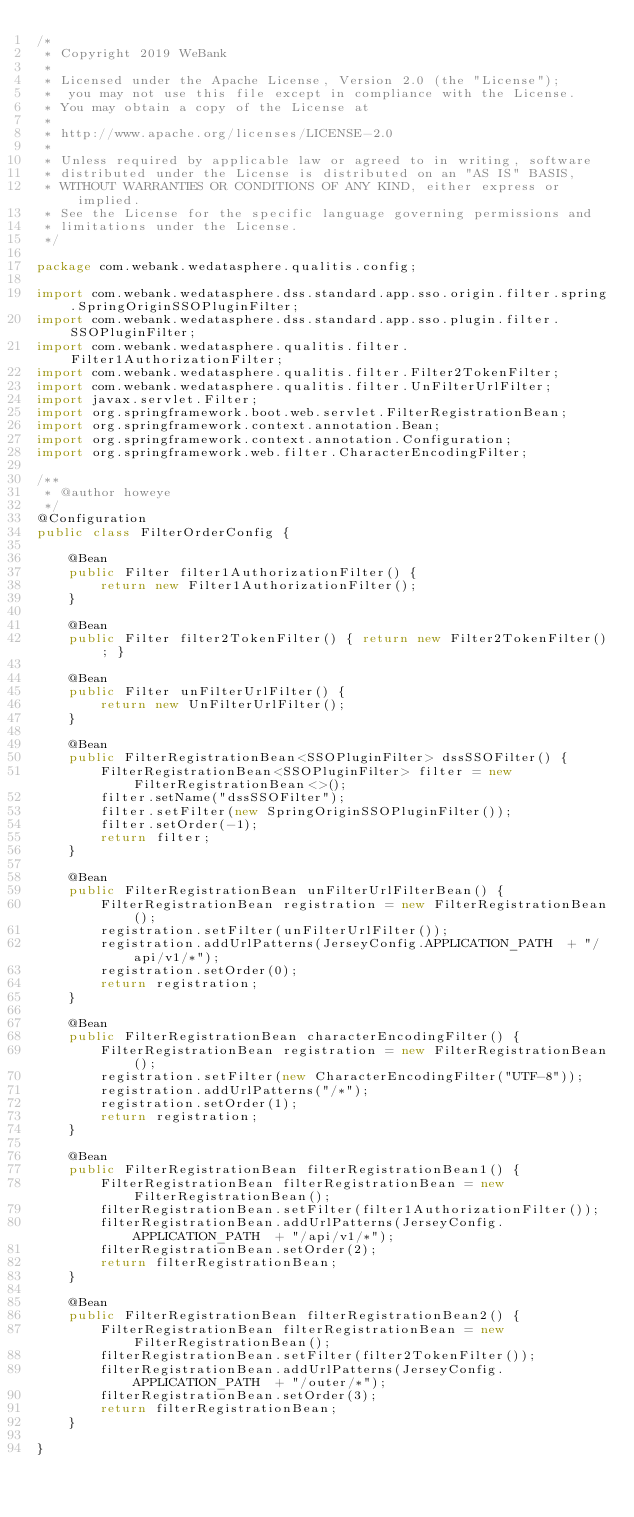<code> <loc_0><loc_0><loc_500><loc_500><_Java_>/*
 * Copyright 2019 WeBank
 *
 * Licensed under the Apache License, Version 2.0 (the "License");
 *  you may not use this file except in compliance with the License.
 * You may obtain a copy of the License at
 *
 * http://www.apache.org/licenses/LICENSE-2.0
 *
 * Unless required by applicable law or agreed to in writing, software
 * distributed under the License is distributed on an "AS IS" BASIS,
 * WITHOUT WARRANTIES OR CONDITIONS OF ANY KIND, either express or implied.
 * See the License for the specific language governing permissions and
 * limitations under the License.
 */

package com.webank.wedatasphere.qualitis.config;

import com.webank.wedatasphere.dss.standard.app.sso.origin.filter.spring.SpringOriginSSOPluginFilter;
import com.webank.wedatasphere.dss.standard.app.sso.plugin.filter.SSOPluginFilter;
import com.webank.wedatasphere.qualitis.filter.Filter1AuthorizationFilter;
import com.webank.wedatasphere.qualitis.filter.Filter2TokenFilter;
import com.webank.wedatasphere.qualitis.filter.UnFilterUrlFilter;
import javax.servlet.Filter;
import org.springframework.boot.web.servlet.FilterRegistrationBean;
import org.springframework.context.annotation.Bean;
import org.springframework.context.annotation.Configuration;
import org.springframework.web.filter.CharacterEncodingFilter;

/**
 * @author howeye
 */
@Configuration
public class FilterOrderConfig {

    @Bean
    public Filter filter1AuthorizationFilter() {
        return new Filter1AuthorizationFilter();
    }

    @Bean
    public Filter filter2TokenFilter() { return new Filter2TokenFilter(); }

    @Bean
    public Filter unFilterUrlFilter() {
        return new UnFilterUrlFilter();
    }

    @Bean
    public FilterRegistrationBean<SSOPluginFilter> dssSSOFilter() {
        FilterRegistrationBean<SSOPluginFilter> filter = new FilterRegistrationBean<>();
        filter.setName("dssSSOFilter");
        filter.setFilter(new SpringOriginSSOPluginFilter());
        filter.setOrder(-1);
        return filter;
    }

    @Bean
    public FilterRegistrationBean unFilterUrlFilterBean() {
        FilterRegistrationBean registration = new FilterRegistrationBean();
        registration.setFilter(unFilterUrlFilter());
        registration.addUrlPatterns(JerseyConfig.APPLICATION_PATH  + "/api/v1/*");
        registration.setOrder(0);
        return registration;
    }

    @Bean
    public FilterRegistrationBean characterEncodingFilter() {
        FilterRegistrationBean registration = new FilterRegistrationBean();
        registration.setFilter(new CharacterEncodingFilter("UTF-8"));
        registration.addUrlPatterns("/*");
        registration.setOrder(1);
        return registration;
    }

    @Bean
    public FilterRegistrationBean filterRegistrationBean1() {
        FilterRegistrationBean filterRegistrationBean = new FilterRegistrationBean();
        filterRegistrationBean.setFilter(filter1AuthorizationFilter());
        filterRegistrationBean.addUrlPatterns(JerseyConfig.APPLICATION_PATH  + "/api/v1/*");
        filterRegistrationBean.setOrder(2);
        return filterRegistrationBean;
    }

    @Bean
    public FilterRegistrationBean filterRegistrationBean2() {
        FilterRegistrationBean filterRegistrationBean = new FilterRegistrationBean();
        filterRegistrationBean.setFilter(filter2TokenFilter());
        filterRegistrationBean.addUrlPatterns(JerseyConfig.APPLICATION_PATH  + "/outer/*");
        filterRegistrationBean.setOrder(3);
        return filterRegistrationBean;
    }

}
</code> 